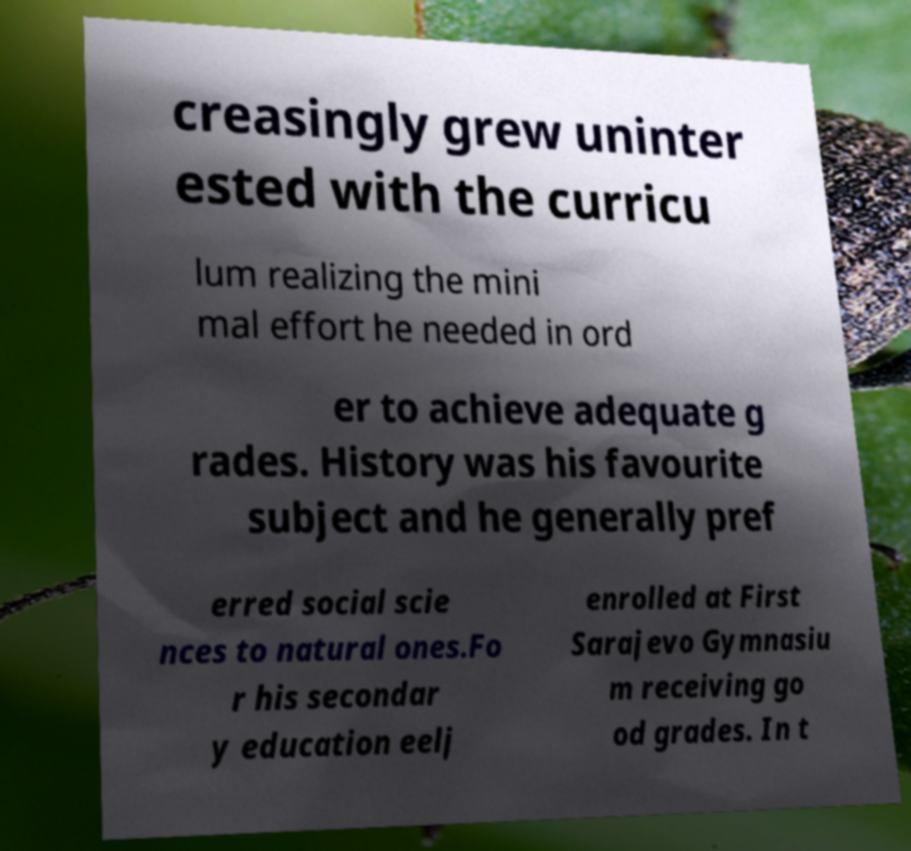Could you extract and type out the text from this image? creasingly grew uninter ested with the curricu lum realizing the mini mal effort he needed in ord er to achieve adequate g rades. History was his favourite subject and he generally pref erred social scie nces to natural ones.Fo r his secondar y education eelj enrolled at First Sarajevo Gymnasiu m receiving go od grades. In t 